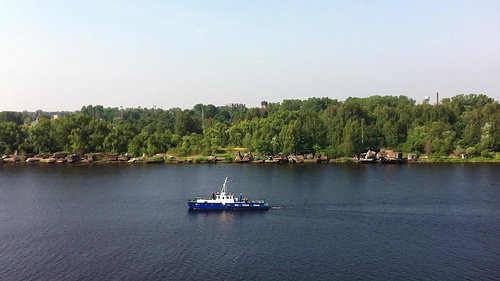Please provide a short description for this region: [0.43, 0.6, 0.47, 0.62]. In this small section, the white cabin of a boat is visible, suggesting it is well-maintained and functional. 